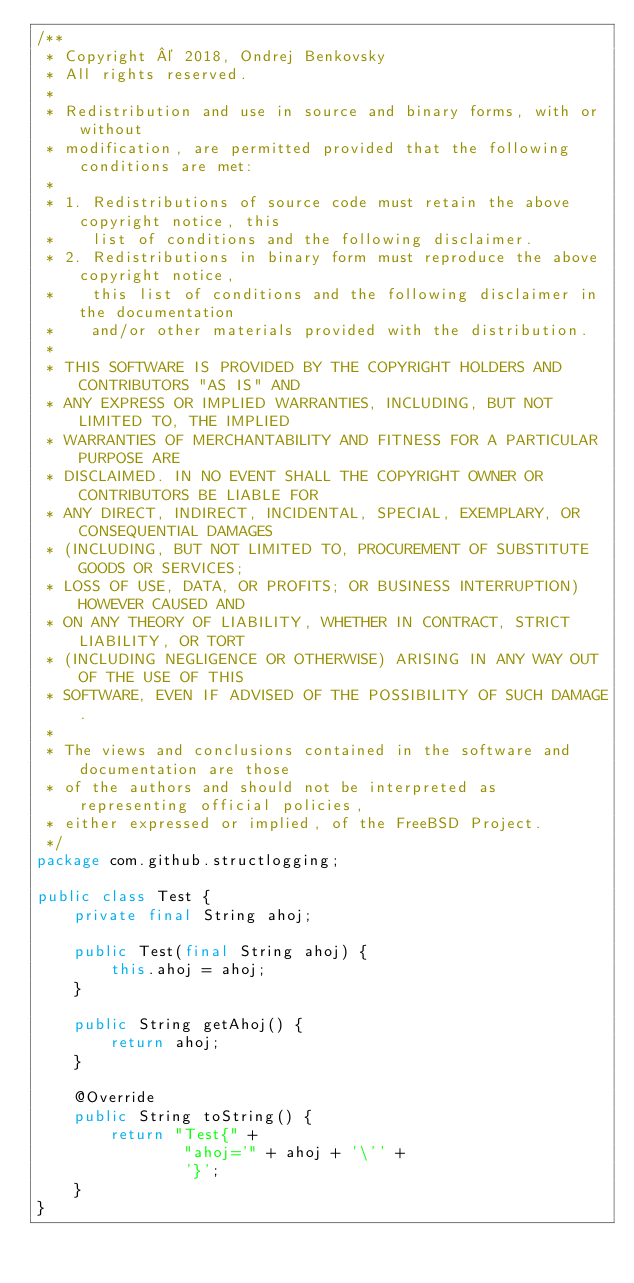Convert code to text. <code><loc_0><loc_0><loc_500><loc_500><_Java_>/**
 * Copyright © 2018, Ondrej Benkovsky
 * All rights reserved.
 *
 * Redistribution and use in source and binary forms, with or without
 * modification, are permitted provided that the following conditions are met:
 *
 * 1. Redistributions of source code must retain the above copyright notice, this
 *    list of conditions and the following disclaimer.
 * 2. Redistributions in binary form must reproduce the above copyright notice,
 *    this list of conditions and the following disclaimer in the documentation
 *    and/or other materials provided with the distribution.
 *
 * THIS SOFTWARE IS PROVIDED BY THE COPYRIGHT HOLDERS AND CONTRIBUTORS "AS IS" AND
 * ANY EXPRESS OR IMPLIED WARRANTIES, INCLUDING, BUT NOT LIMITED TO, THE IMPLIED
 * WARRANTIES OF MERCHANTABILITY AND FITNESS FOR A PARTICULAR PURPOSE ARE
 * DISCLAIMED. IN NO EVENT SHALL THE COPYRIGHT OWNER OR CONTRIBUTORS BE LIABLE FOR
 * ANY DIRECT, INDIRECT, INCIDENTAL, SPECIAL, EXEMPLARY, OR CONSEQUENTIAL DAMAGES
 * (INCLUDING, BUT NOT LIMITED TO, PROCUREMENT OF SUBSTITUTE GOODS OR SERVICES;
 * LOSS OF USE, DATA, OR PROFITS; OR BUSINESS INTERRUPTION) HOWEVER CAUSED AND
 * ON ANY THEORY OF LIABILITY, WHETHER IN CONTRACT, STRICT LIABILITY, OR TORT
 * (INCLUDING NEGLIGENCE OR OTHERWISE) ARISING IN ANY WAY OUT OF THE USE OF THIS
 * SOFTWARE, EVEN IF ADVISED OF THE POSSIBILITY OF SUCH DAMAGE.
 *
 * The views and conclusions contained in the software and documentation are those
 * of the authors and should not be interpreted as representing official policies,
 * either expressed or implied, of the FreeBSD Project.
 */
package com.github.structlogging;

public class Test {
    private final String ahoj;

    public Test(final String ahoj) {
        this.ahoj = ahoj;
    }

    public String getAhoj() {
        return ahoj;
    }

    @Override
    public String toString() {
        return "Test{" +
                "ahoj='" + ahoj + '\'' +
                '}';
    }
}
</code> 